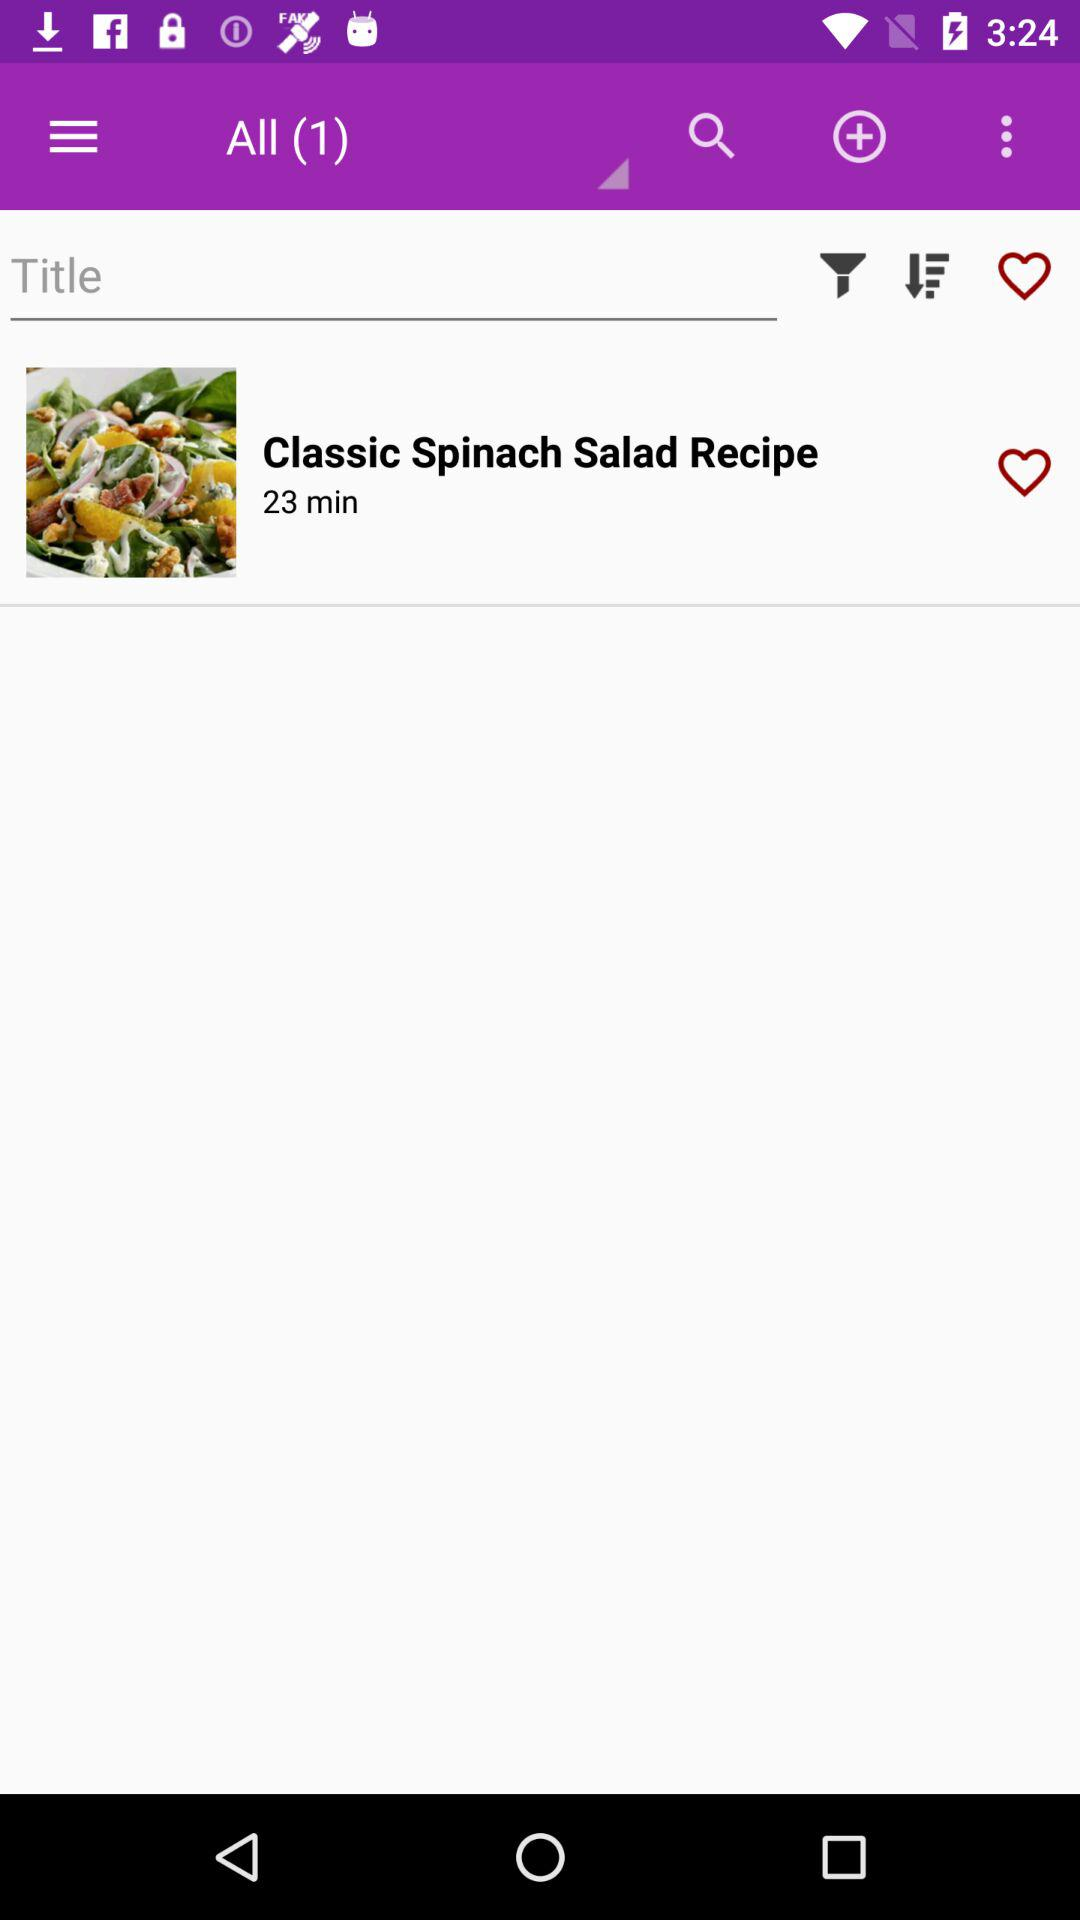What is the time duration of the "Spinach Salad Recipe"? The time duration is 23 minutes. 